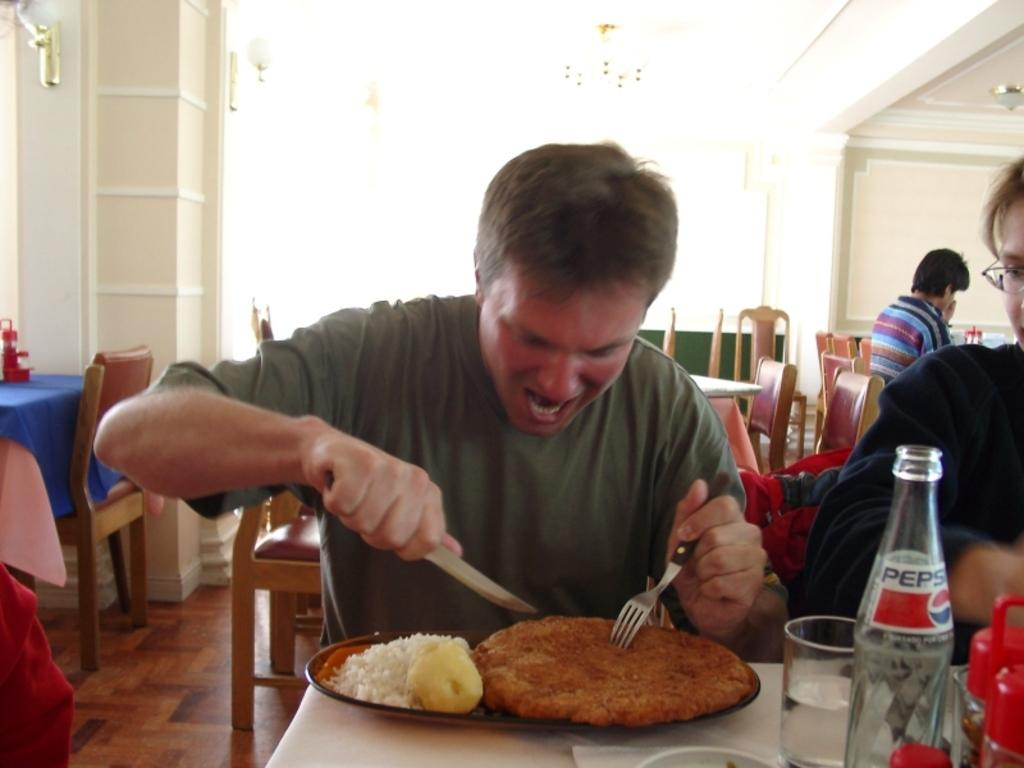<image>
Write a terse but informative summary of the picture. the word Pepsi that is on the bottle 